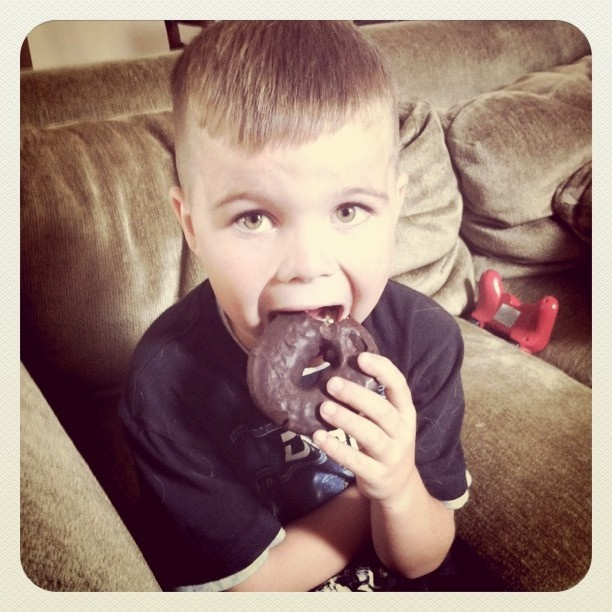Describe the objects in this image and their specific colors. I can see people in ivory, black, beige, tan, and maroon tones, couch in ivory, gray, maroon, and tan tones, couch in ivory, black, maroon, gray, and tan tones, and donut in ivory, gray, darkgray, brown, and purple tones in this image. 